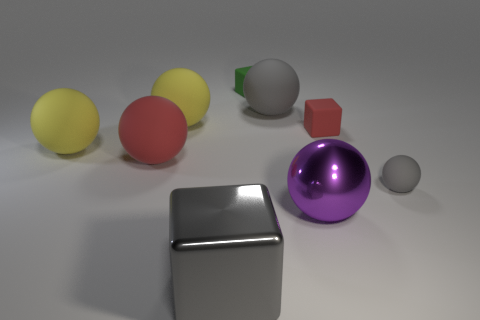What is the size of the yellow matte ball to the right of the red matte object that is on the left side of the tiny red object?
Ensure brevity in your answer.  Large. How many yellow things are the same size as the red ball?
Your answer should be compact. 2. There is a metal thing that is left of the purple metal ball; is its color the same as the matte object in front of the large red rubber ball?
Offer a terse response. Yes. There is a red matte block; are there any large things to the right of it?
Your response must be concise. No. What is the color of the ball that is to the left of the big gray matte object and behind the tiny red object?
Your answer should be very brief. Yellow. Is there a ball of the same color as the shiny block?
Offer a terse response. Yes. Does the big sphere in front of the small gray rubber sphere have the same material as the red object that is left of the large shiny block?
Provide a short and direct response. No. There is a gray matte thing behind the large red sphere; what is its size?
Give a very brief answer. Large. What size is the purple sphere?
Ensure brevity in your answer.  Large. There is a yellow object that is on the left side of the red matte thing that is on the left side of the large gray thing in front of the purple ball; what is its size?
Offer a terse response. Large. 